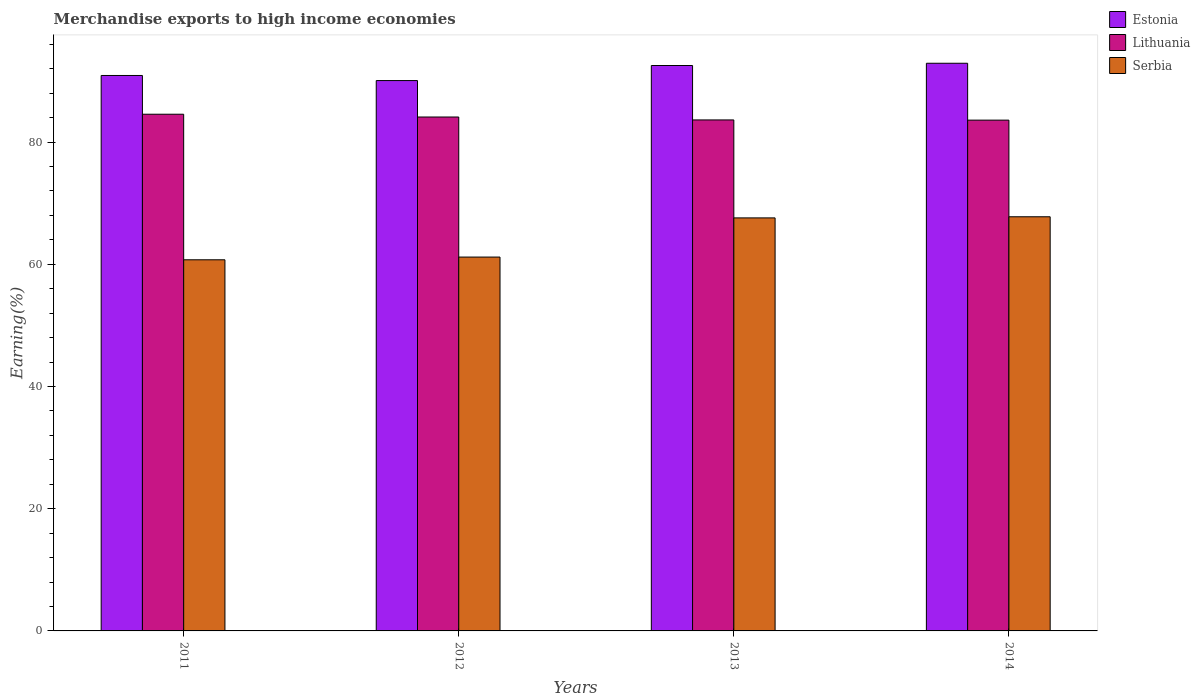How many different coloured bars are there?
Make the answer very short. 3. What is the label of the 3rd group of bars from the left?
Your answer should be very brief. 2013. What is the percentage of amount earned from merchandise exports in Estonia in 2014?
Your response must be concise. 92.89. Across all years, what is the maximum percentage of amount earned from merchandise exports in Estonia?
Keep it short and to the point. 92.89. Across all years, what is the minimum percentage of amount earned from merchandise exports in Estonia?
Provide a short and direct response. 90.06. In which year was the percentage of amount earned from merchandise exports in Lithuania minimum?
Keep it short and to the point. 2014. What is the total percentage of amount earned from merchandise exports in Serbia in the graph?
Provide a short and direct response. 257.27. What is the difference between the percentage of amount earned from merchandise exports in Serbia in 2012 and that in 2013?
Offer a very short reply. -6.41. What is the difference between the percentage of amount earned from merchandise exports in Estonia in 2012 and the percentage of amount earned from merchandise exports in Lithuania in 2013?
Offer a very short reply. 6.44. What is the average percentage of amount earned from merchandise exports in Estonia per year?
Make the answer very short. 91.59. In the year 2012, what is the difference between the percentage of amount earned from merchandise exports in Lithuania and percentage of amount earned from merchandise exports in Estonia?
Give a very brief answer. -5.96. What is the ratio of the percentage of amount earned from merchandise exports in Estonia in 2012 to that in 2014?
Ensure brevity in your answer.  0.97. Is the difference between the percentage of amount earned from merchandise exports in Lithuania in 2011 and 2012 greater than the difference between the percentage of amount earned from merchandise exports in Estonia in 2011 and 2012?
Your answer should be very brief. No. What is the difference between the highest and the second highest percentage of amount earned from merchandise exports in Serbia?
Offer a terse response. 0.18. What is the difference between the highest and the lowest percentage of amount earned from merchandise exports in Estonia?
Ensure brevity in your answer.  2.83. What does the 1st bar from the left in 2012 represents?
Offer a very short reply. Estonia. What does the 3rd bar from the right in 2012 represents?
Provide a short and direct response. Estonia. Is it the case that in every year, the sum of the percentage of amount earned from merchandise exports in Estonia and percentage of amount earned from merchandise exports in Serbia is greater than the percentage of amount earned from merchandise exports in Lithuania?
Your answer should be compact. Yes. How many bars are there?
Your answer should be compact. 12. Are all the bars in the graph horizontal?
Make the answer very short. No. What is the difference between two consecutive major ticks on the Y-axis?
Give a very brief answer. 20. Are the values on the major ticks of Y-axis written in scientific E-notation?
Keep it short and to the point. No. Does the graph contain grids?
Offer a terse response. No. Where does the legend appear in the graph?
Keep it short and to the point. Top right. How many legend labels are there?
Your response must be concise. 3. What is the title of the graph?
Make the answer very short. Merchandise exports to high income economies. Does "Low & middle income" appear as one of the legend labels in the graph?
Your answer should be compact. No. What is the label or title of the Y-axis?
Ensure brevity in your answer.  Earning(%). What is the Earning(%) of Estonia in 2011?
Ensure brevity in your answer.  90.89. What is the Earning(%) of Lithuania in 2011?
Provide a succinct answer. 84.55. What is the Earning(%) of Serbia in 2011?
Provide a succinct answer. 60.73. What is the Earning(%) of Estonia in 2012?
Your answer should be compact. 90.06. What is the Earning(%) in Lithuania in 2012?
Provide a short and direct response. 84.1. What is the Earning(%) in Serbia in 2012?
Your answer should be very brief. 61.18. What is the Earning(%) of Estonia in 2013?
Give a very brief answer. 92.53. What is the Earning(%) of Lithuania in 2013?
Offer a very short reply. 83.62. What is the Earning(%) of Serbia in 2013?
Offer a very short reply. 67.59. What is the Earning(%) in Estonia in 2014?
Provide a succinct answer. 92.89. What is the Earning(%) in Lithuania in 2014?
Your response must be concise. 83.59. What is the Earning(%) of Serbia in 2014?
Your answer should be very brief. 67.77. Across all years, what is the maximum Earning(%) of Estonia?
Make the answer very short. 92.89. Across all years, what is the maximum Earning(%) of Lithuania?
Provide a short and direct response. 84.55. Across all years, what is the maximum Earning(%) in Serbia?
Make the answer very short. 67.77. Across all years, what is the minimum Earning(%) of Estonia?
Your response must be concise. 90.06. Across all years, what is the minimum Earning(%) in Lithuania?
Your response must be concise. 83.59. Across all years, what is the minimum Earning(%) of Serbia?
Provide a succinct answer. 60.73. What is the total Earning(%) in Estonia in the graph?
Give a very brief answer. 366.38. What is the total Earning(%) of Lithuania in the graph?
Give a very brief answer. 335.86. What is the total Earning(%) in Serbia in the graph?
Give a very brief answer. 257.27. What is the difference between the Earning(%) of Estonia in 2011 and that in 2012?
Make the answer very short. 0.83. What is the difference between the Earning(%) of Lithuania in 2011 and that in 2012?
Provide a short and direct response. 0.46. What is the difference between the Earning(%) in Serbia in 2011 and that in 2012?
Your answer should be very brief. -0.45. What is the difference between the Earning(%) in Estonia in 2011 and that in 2013?
Make the answer very short. -1.63. What is the difference between the Earning(%) of Lithuania in 2011 and that in 2013?
Offer a very short reply. 0.93. What is the difference between the Earning(%) of Serbia in 2011 and that in 2013?
Your answer should be compact. -6.86. What is the difference between the Earning(%) of Estonia in 2011 and that in 2014?
Offer a very short reply. -2. What is the difference between the Earning(%) in Lithuania in 2011 and that in 2014?
Your answer should be compact. 0.97. What is the difference between the Earning(%) in Serbia in 2011 and that in 2014?
Keep it short and to the point. -7.04. What is the difference between the Earning(%) of Estonia in 2012 and that in 2013?
Your response must be concise. -2.46. What is the difference between the Earning(%) in Lithuania in 2012 and that in 2013?
Provide a succinct answer. 0.48. What is the difference between the Earning(%) of Serbia in 2012 and that in 2013?
Keep it short and to the point. -6.41. What is the difference between the Earning(%) of Estonia in 2012 and that in 2014?
Offer a very short reply. -2.83. What is the difference between the Earning(%) in Lithuania in 2012 and that in 2014?
Provide a succinct answer. 0.51. What is the difference between the Earning(%) in Serbia in 2012 and that in 2014?
Your response must be concise. -6.59. What is the difference between the Earning(%) of Estonia in 2013 and that in 2014?
Provide a short and direct response. -0.37. What is the difference between the Earning(%) in Lithuania in 2013 and that in 2014?
Your response must be concise. 0.03. What is the difference between the Earning(%) of Serbia in 2013 and that in 2014?
Provide a short and direct response. -0.18. What is the difference between the Earning(%) of Estonia in 2011 and the Earning(%) of Lithuania in 2012?
Provide a short and direct response. 6.8. What is the difference between the Earning(%) in Estonia in 2011 and the Earning(%) in Serbia in 2012?
Your answer should be very brief. 29.72. What is the difference between the Earning(%) of Lithuania in 2011 and the Earning(%) of Serbia in 2012?
Provide a short and direct response. 23.38. What is the difference between the Earning(%) in Estonia in 2011 and the Earning(%) in Lithuania in 2013?
Your response must be concise. 7.27. What is the difference between the Earning(%) in Estonia in 2011 and the Earning(%) in Serbia in 2013?
Keep it short and to the point. 23.31. What is the difference between the Earning(%) of Lithuania in 2011 and the Earning(%) of Serbia in 2013?
Your response must be concise. 16.97. What is the difference between the Earning(%) of Estonia in 2011 and the Earning(%) of Lithuania in 2014?
Your answer should be compact. 7.31. What is the difference between the Earning(%) in Estonia in 2011 and the Earning(%) in Serbia in 2014?
Provide a short and direct response. 23.12. What is the difference between the Earning(%) in Lithuania in 2011 and the Earning(%) in Serbia in 2014?
Offer a terse response. 16.78. What is the difference between the Earning(%) of Estonia in 2012 and the Earning(%) of Lithuania in 2013?
Your answer should be very brief. 6.44. What is the difference between the Earning(%) in Estonia in 2012 and the Earning(%) in Serbia in 2013?
Ensure brevity in your answer.  22.47. What is the difference between the Earning(%) in Lithuania in 2012 and the Earning(%) in Serbia in 2013?
Your answer should be very brief. 16.51. What is the difference between the Earning(%) of Estonia in 2012 and the Earning(%) of Lithuania in 2014?
Offer a very short reply. 6.47. What is the difference between the Earning(%) of Estonia in 2012 and the Earning(%) of Serbia in 2014?
Provide a short and direct response. 22.29. What is the difference between the Earning(%) in Lithuania in 2012 and the Earning(%) in Serbia in 2014?
Provide a short and direct response. 16.33. What is the difference between the Earning(%) of Estonia in 2013 and the Earning(%) of Lithuania in 2014?
Give a very brief answer. 8.94. What is the difference between the Earning(%) in Estonia in 2013 and the Earning(%) in Serbia in 2014?
Ensure brevity in your answer.  24.75. What is the difference between the Earning(%) in Lithuania in 2013 and the Earning(%) in Serbia in 2014?
Offer a terse response. 15.85. What is the average Earning(%) in Estonia per year?
Your answer should be compact. 91.59. What is the average Earning(%) in Lithuania per year?
Offer a terse response. 83.96. What is the average Earning(%) of Serbia per year?
Your answer should be compact. 64.32. In the year 2011, what is the difference between the Earning(%) in Estonia and Earning(%) in Lithuania?
Provide a short and direct response. 6.34. In the year 2011, what is the difference between the Earning(%) in Estonia and Earning(%) in Serbia?
Make the answer very short. 30.16. In the year 2011, what is the difference between the Earning(%) of Lithuania and Earning(%) of Serbia?
Your answer should be compact. 23.82. In the year 2012, what is the difference between the Earning(%) in Estonia and Earning(%) in Lithuania?
Offer a terse response. 5.96. In the year 2012, what is the difference between the Earning(%) in Estonia and Earning(%) in Serbia?
Offer a very short reply. 28.88. In the year 2012, what is the difference between the Earning(%) of Lithuania and Earning(%) of Serbia?
Make the answer very short. 22.92. In the year 2013, what is the difference between the Earning(%) in Estonia and Earning(%) in Lithuania?
Offer a terse response. 8.91. In the year 2013, what is the difference between the Earning(%) of Estonia and Earning(%) of Serbia?
Your answer should be compact. 24.94. In the year 2013, what is the difference between the Earning(%) of Lithuania and Earning(%) of Serbia?
Offer a very short reply. 16.03. In the year 2014, what is the difference between the Earning(%) in Estonia and Earning(%) in Lithuania?
Provide a succinct answer. 9.31. In the year 2014, what is the difference between the Earning(%) in Estonia and Earning(%) in Serbia?
Ensure brevity in your answer.  25.12. In the year 2014, what is the difference between the Earning(%) of Lithuania and Earning(%) of Serbia?
Your answer should be compact. 15.82. What is the ratio of the Earning(%) of Estonia in 2011 to that in 2012?
Offer a terse response. 1.01. What is the ratio of the Earning(%) in Lithuania in 2011 to that in 2012?
Offer a terse response. 1.01. What is the ratio of the Earning(%) in Estonia in 2011 to that in 2013?
Keep it short and to the point. 0.98. What is the ratio of the Earning(%) of Lithuania in 2011 to that in 2013?
Offer a terse response. 1.01. What is the ratio of the Earning(%) in Serbia in 2011 to that in 2013?
Offer a very short reply. 0.9. What is the ratio of the Earning(%) in Estonia in 2011 to that in 2014?
Your answer should be compact. 0.98. What is the ratio of the Earning(%) in Lithuania in 2011 to that in 2014?
Your answer should be very brief. 1.01. What is the ratio of the Earning(%) of Serbia in 2011 to that in 2014?
Make the answer very short. 0.9. What is the ratio of the Earning(%) in Estonia in 2012 to that in 2013?
Offer a terse response. 0.97. What is the ratio of the Earning(%) in Serbia in 2012 to that in 2013?
Your answer should be compact. 0.91. What is the ratio of the Earning(%) of Estonia in 2012 to that in 2014?
Provide a short and direct response. 0.97. What is the ratio of the Earning(%) of Lithuania in 2012 to that in 2014?
Provide a succinct answer. 1.01. What is the ratio of the Earning(%) of Serbia in 2012 to that in 2014?
Make the answer very short. 0.9. What is the ratio of the Earning(%) of Serbia in 2013 to that in 2014?
Your response must be concise. 1. What is the difference between the highest and the second highest Earning(%) in Estonia?
Provide a short and direct response. 0.37. What is the difference between the highest and the second highest Earning(%) in Lithuania?
Your response must be concise. 0.46. What is the difference between the highest and the second highest Earning(%) in Serbia?
Your answer should be compact. 0.18. What is the difference between the highest and the lowest Earning(%) in Estonia?
Provide a short and direct response. 2.83. What is the difference between the highest and the lowest Earning(%) in Lithuania?
Your answer should be compact. 0.97. What is the difference between the highest and the lowest Earning(%) in Serbia?
Provide a short and direct response. 7.04. 